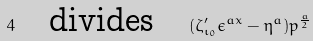<formula> <loc_0><loc_0><loc_500><loc_500>4 \quad \text {divides} \quad ( \zeta _ { \iota _ { 0 } } ^ { \prime } \epsilon ^ { a x } - \eta ^ { a } ) p ^ { \frac { a } { 2 } }</formula> 